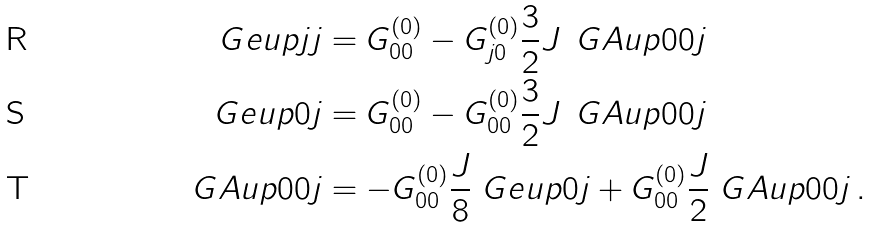<formula> <loc_0><loc_0><loc_500><loc_500>\ G e u p { j j } & = G _ { 0 0 } ^ { ( 0 ) } - G _ { j 0 } ^ { ( 0 ) } \frac { 3 } { 2 } J \, \ G A u p { 0 0 j } \\ \ G e u p { 0 j } & = G _ { 0 0 } ^ { ( 0 ) } - G _ { 0 0 } ^ { ( 0 ) } \frac { 3 } { 2 } J \, \ G A u p { 0 0 j } \\ \ G A u p { 0 0 j } & = - G _ { 0 0 } ^ { ( 0 ) } \frac { J } { 8 } \ G e u p { 0 j } + G _ { 0 0 } ^ { ( 0 ) } \frac { J } { 2 } \ G A u p { 0 0 j } \, .</formula> 